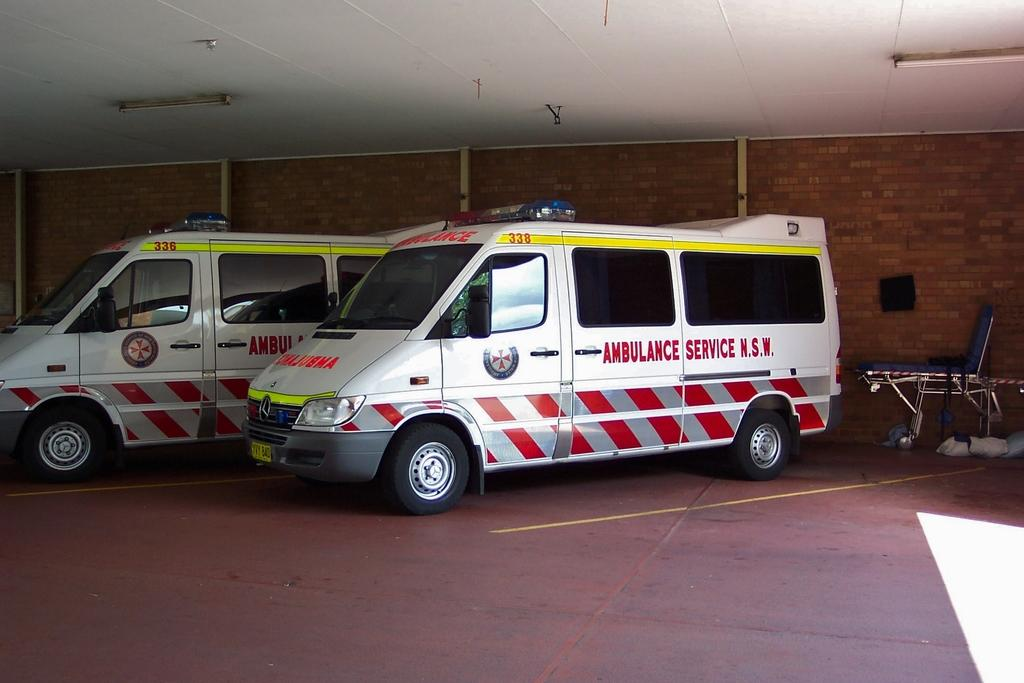<image>
Create a compact narrative representing the image presented. two ambulances are sitting in the parking lot 